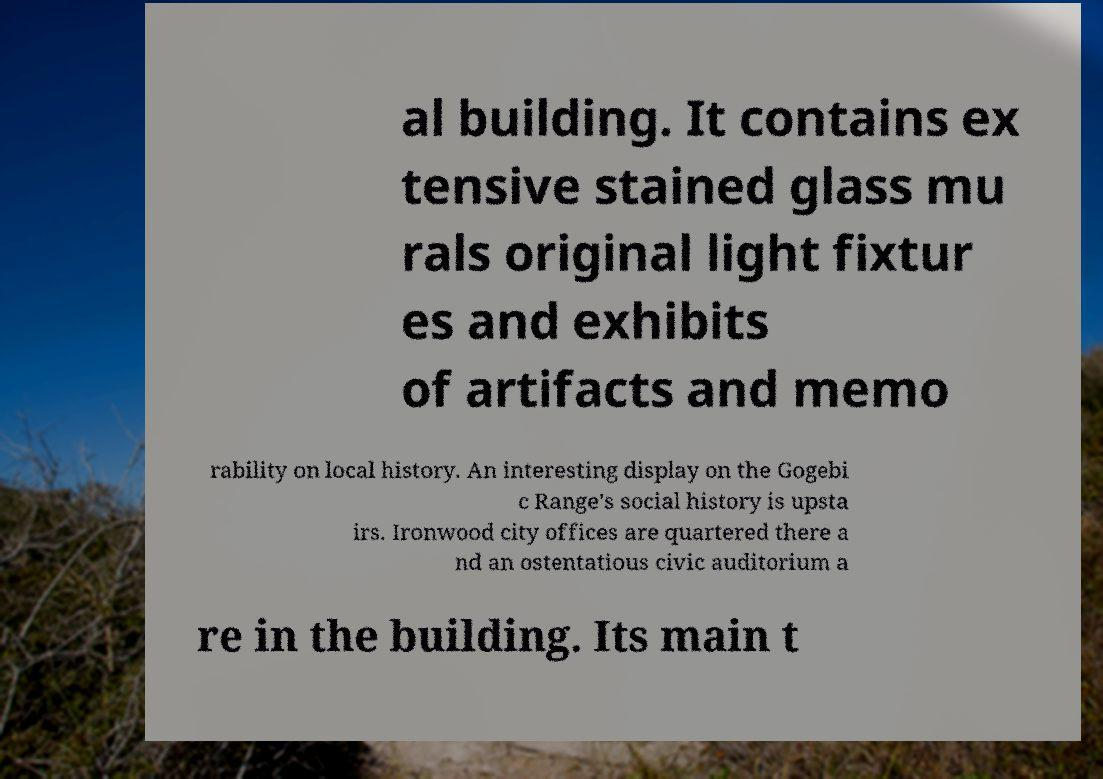Can you read and provide the text displayed in the image?This photo seems to have some interesting text. Can you extract and type it out for me? al building. It contains ex tensive stained glass mu rals original light fixtur es and exhibits of artifacts and memo rability on local history. An interesting display on the Gogebi c Range's social history is upsta irs. Ironwood city offices are quartered there a nd an ostentatious civic auditorium a re in the building. Its main t 